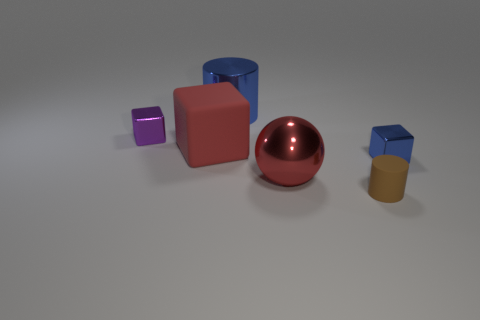Subtract all metal cubes. How many cubes are left? 1 Add 1 large blocks. How many objects exist? 7 Subtract all blue blocks. How many blocks are left? 2 Subtract 1 balls. How many balls are left? 0 Subtract all cyan cylinders. How many purple blocks are left? 1 Subtract all small rubber things. Subtract all blue objects. How many objects are left? 3 Add 2 large blue shiny cylinders. How many large blue shiny cylinders are left? 3 Add 3 tiny brown cylinders. How many tiny brown cylinders exist? 4 Subtract 0 blue spheres. How many objects are left? 6 Subtract all balls. How many objects are left? 5 